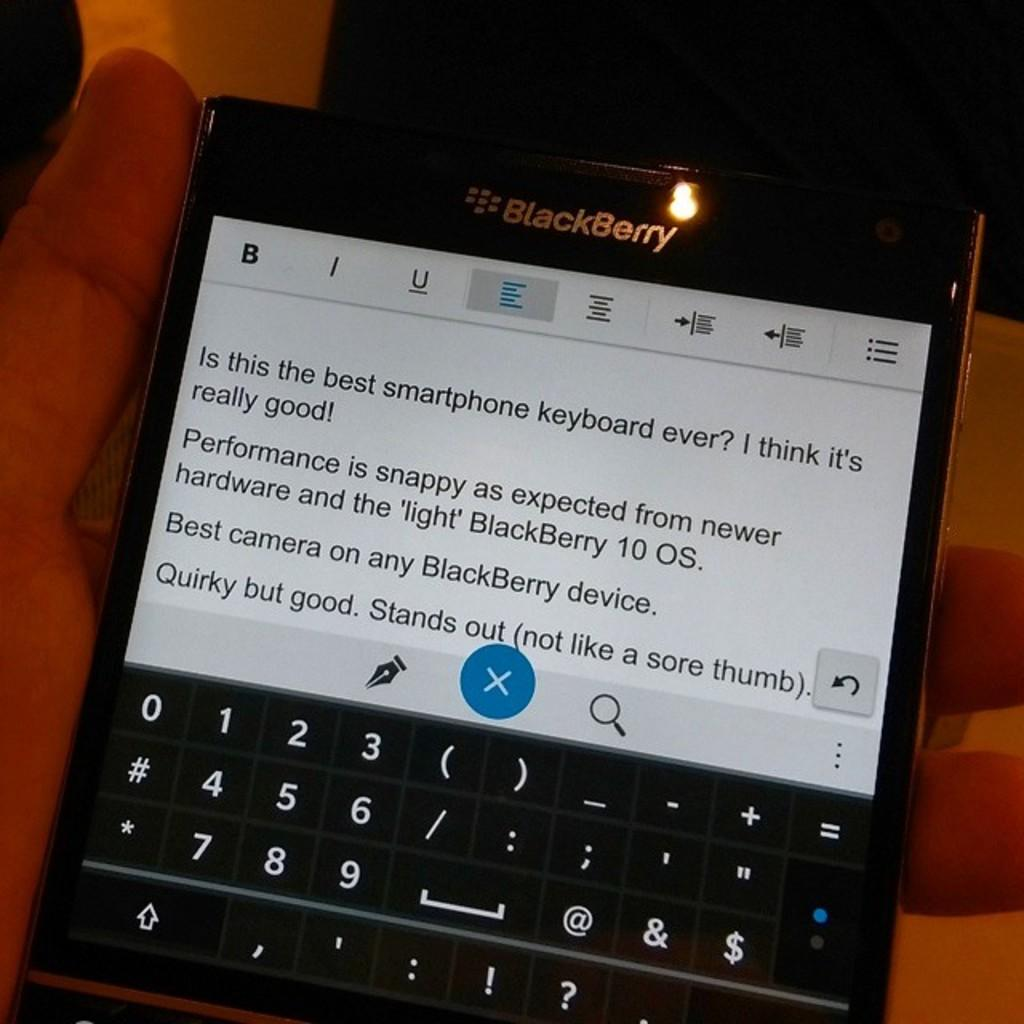Provide a one-sentence caption for the provided image. A BlackBerry phone claims to have "best camera on any BlackBerry device". 